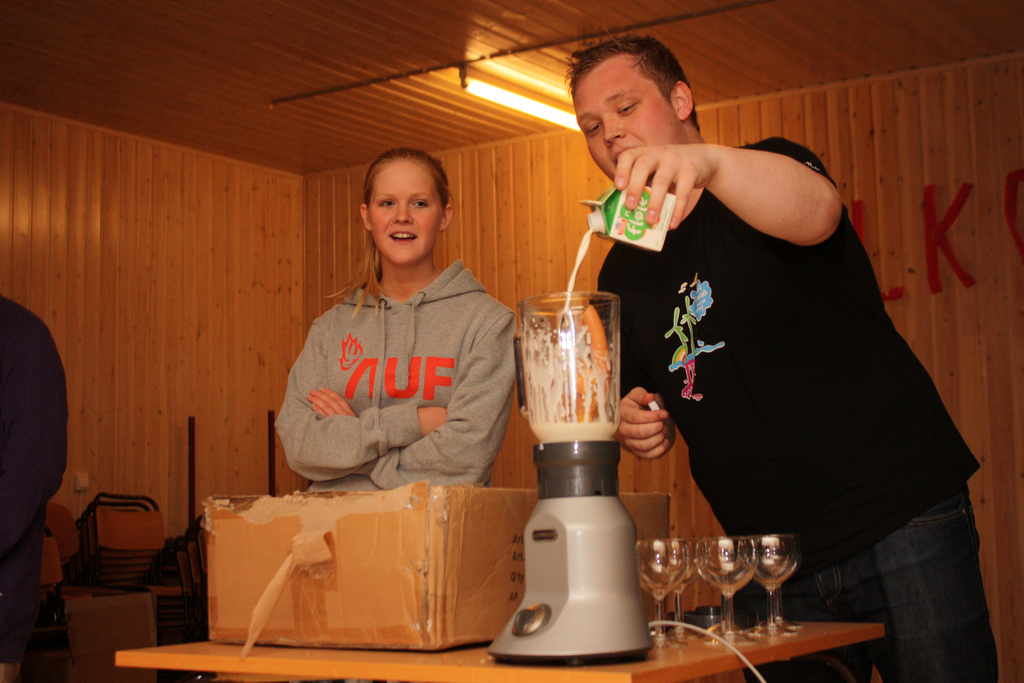Provide a one-sentence caption for the provided image. A young woman in a grey 'UF' sweatshirt watches intently as a young man adds juice to a blender, in a warm, wood-paneled room, suggesting a casual and fun cooking or preparation activity. 